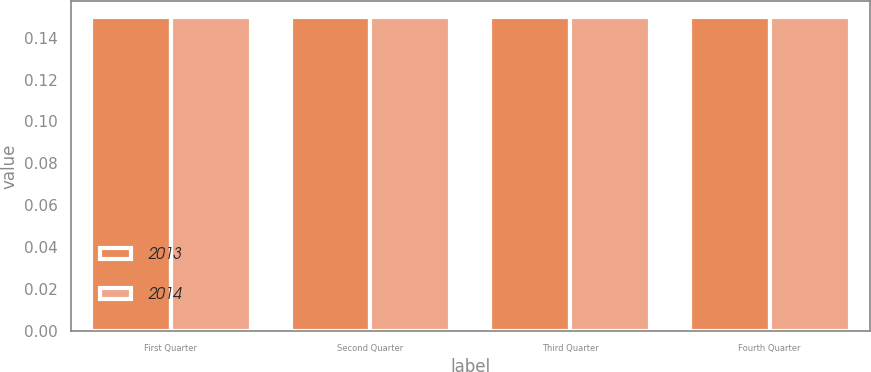Convert chart. <chart><loc_0><loc_0><loc_500><loc_500><stacked_bar_chart><ecel><fcel>First Quarter<fcel>Second Quarter<fcel>Third Quarter<fcel>Fourth Quarter<nl><fcel>2013<fcel>0.15<fcel>0.15<fcel>0.15<fcel>0.15<nl><fcel>2014<fcel>0.15<fcel>0.15<fcel>0.15<fcel>0.15<nl></chart> 